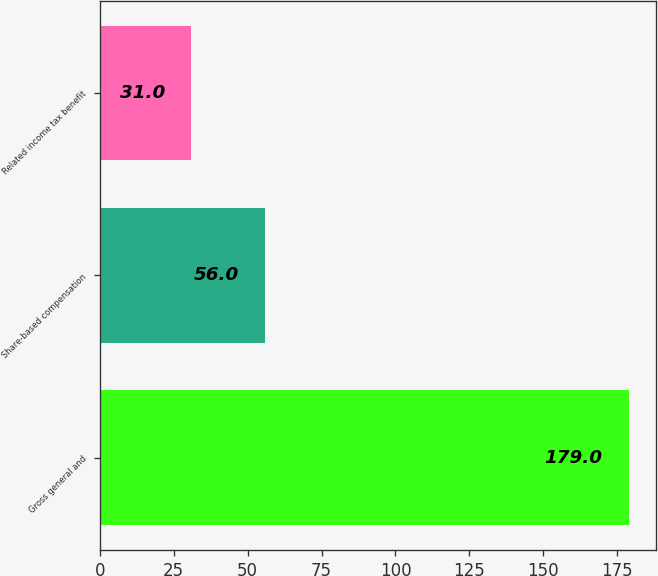Convert chart. <chart><loc_0><loc_0><loc_500><loc_500><bar_chart><fcel>Gross general and<fcel>Share-based compensation<fcel>Related income tax benefit<nl><fcel>179<fcel>56<fcel>31<nl></chart> 